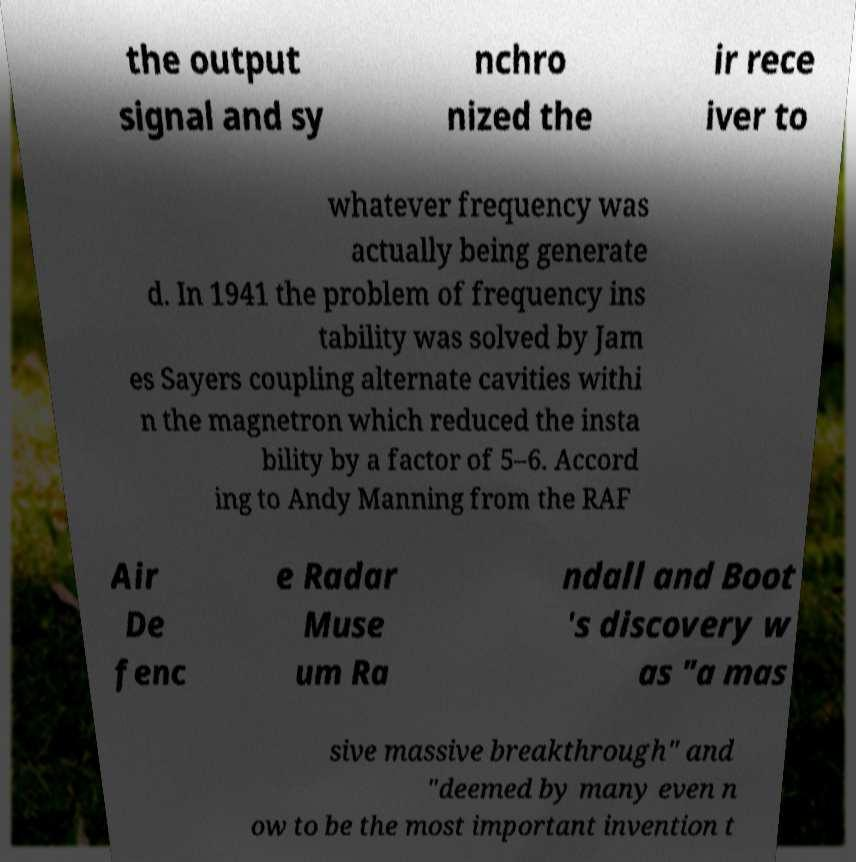Please read and relay the text visible in this image. What does it say? the output signal and sy nchro nized the ir rece iver to whatever frequency was actually being generate d. In 1941 the problem of frequency ins tability was solved by Jam es Sayers coupling alternate cavities withi n the magnetron which reduced the insta bility by a factor of 5–6. Accord ing to Andy Manning from the RAF Air De fenc e Radar Muse um Ra ndall and Boot 's discovery w as "a mas sive massive breakthrough" and "deemed by many even n ow to be the most important invention t 